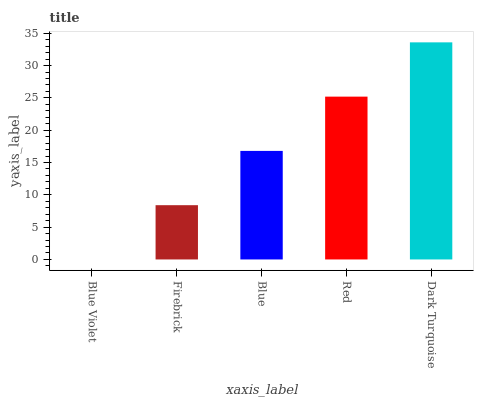Is Blue Violet the minimum?
Answer yes or no. Yes. Is Dark Turquoise the maximum?
Answer yes or no. Yes. Is Firebrick the minimum?
Answer yes or no. No. Is Firebrick the maximum?
Answer yes or no. No. Is Firebrick greater than Blue Violet?
Answer yes or no. Yes. Is Blue Violet less than Firebrick?
Answer yes or no. Yes. Is Blue Violet greater than Firebrick?
Answer yes or no. No. Is Firebrick less than Blue Violet?
Answer yes or no. No. Is Blue the high median?
Answer yes or no. Yes. Is Blue the low median?
Answer yes or no. Yes. Is Firebrick the high median?
Answer yes or no. No. Is Red the low median?
Answer yes or no. No. 